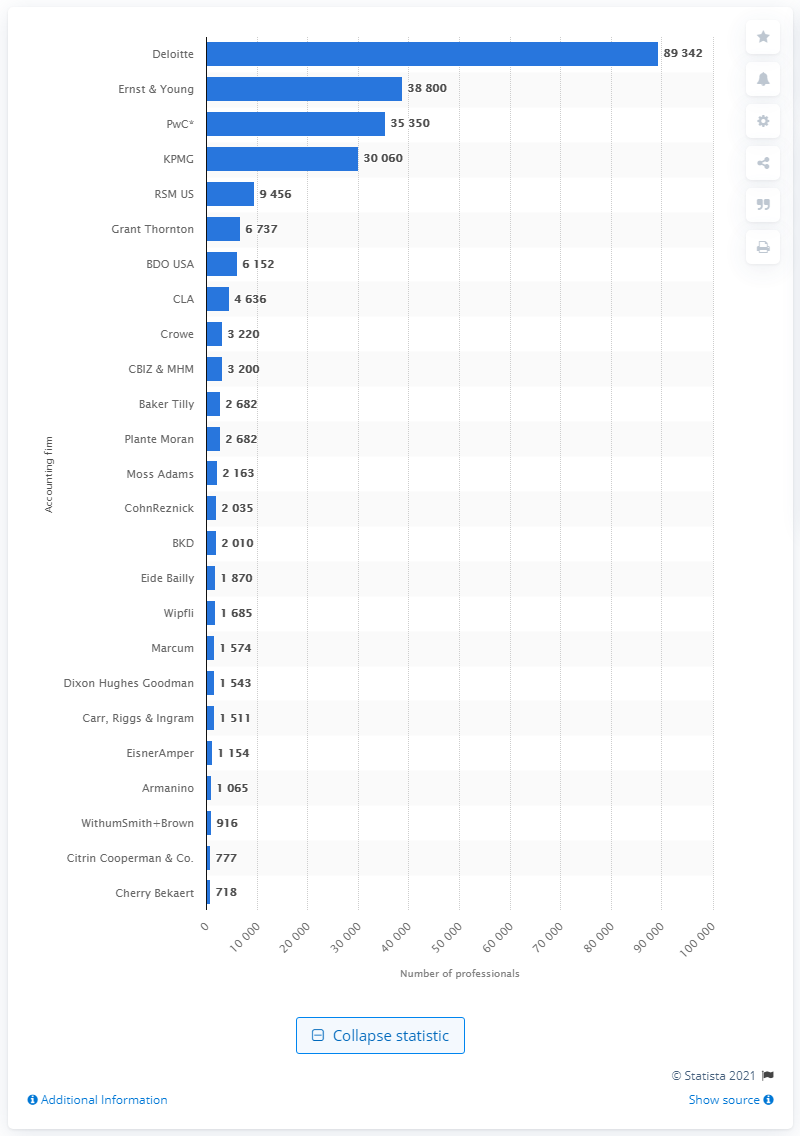Give some essential details in this illustration. Deloitte is the largest accounting firm in the United States. 